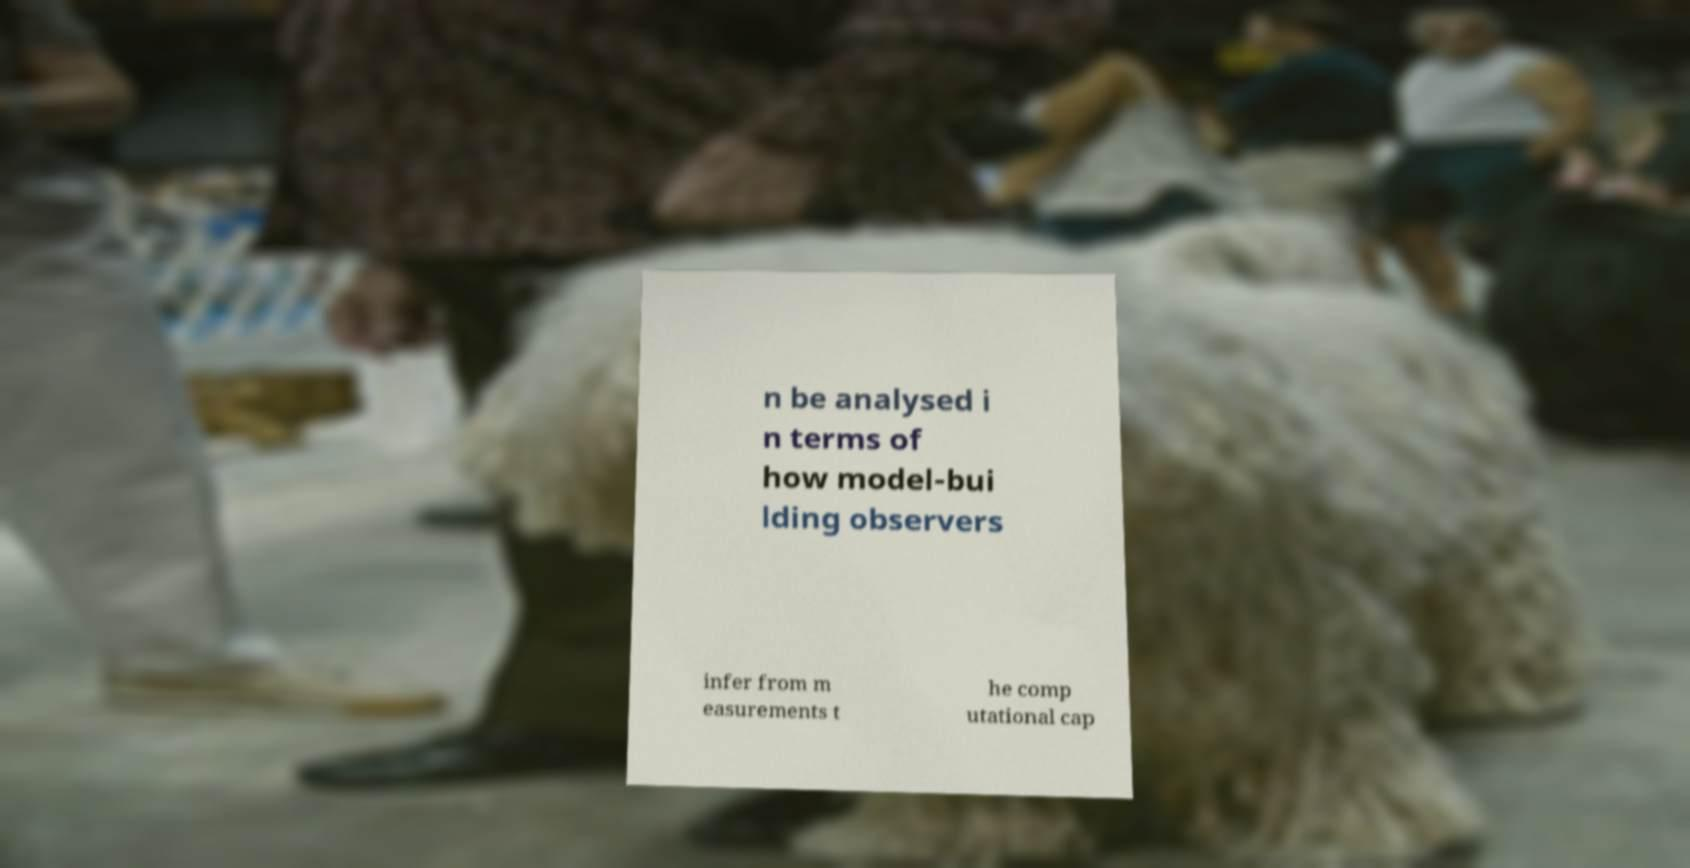For documentation purposes, I need the text within this image transcribed. Could you provide that? n be analysed i n terms of how model-bui lding observers infer from m easurements t he comp utational cap 